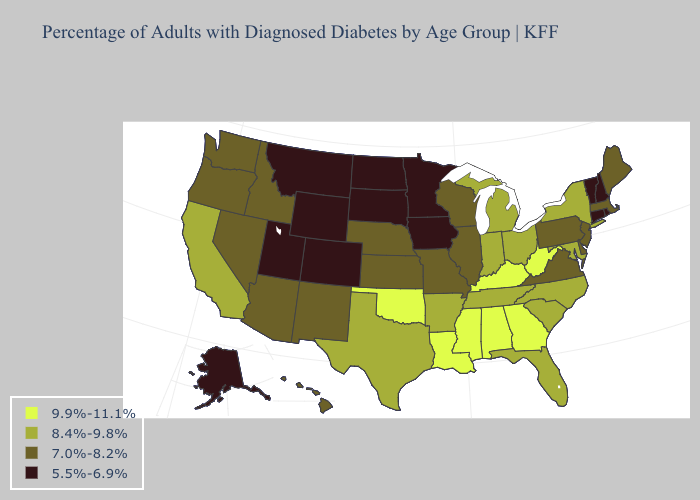What is the value of Arizona?
Give a very brief answer. 7.0%-8.2%. Name the states that have a value in the range 8.4%-9.8%?
Write a very short answer. Arkansas, California, Florida, Indiana, Maryland, Michigan, New York, North Carolina, Ohio, South Carolina, Tennessee, Texas. What is the highest value in states that border Indiana?
Be succinct. 9.9%-11.1%. Which states hav the highest value in the MidWest?
Short answer required. Indiana, Michigan, Ohio. What is the lowest value in states that border Montana?
Short answer required. 5.5%-6.9%. What is the value of Montana?
Short answer required. 5.5%-6.9%. Name the states that have a value in the range 8.4%-9.8%?
Give a very brief answer. Arkansas, California, Florida, Indiana, Maryland, Michigan, New York, North Carolina, Ohio, South Carolina, Tennessee, Texas. Does New Mexico have a higher value than Ohio?
Write a very short answer. No. Which states hav the highest value in the Northeast?
Give a very brief answer. New York. What is the highest value in states that border Maryland?
Concise answer only. 9.9%-11.1%. What is the value of Minnesota?
Answer briefly. 5.5%-6.9%. Name the states that have a value in the range 8.4%-9.8%?
Be succinct. Arkansas, California, Florida, Indiana, Maryland, Michigan, New York, North Carolina, Ohio, South Carolina, Tennessee, Texas. Name the states that have a value in the range 7.0%-8.2%?
Answer briefly. Arizona, Delaware, Hawaii, Idaho, Illinois, Kansas, Maine, Massachusetts, Missouri, Nebraska, Nevada, New Jersey, New Mexico, Oregon, Pennsylvania, Virginia, Washington, Wisconsin. Name the states that have a value in the range 5.5%-6.9%?
Concise answer only. Alaska, Colorado, Connecticut, Iowa, Minnesota, Montana, New Hampshire, North Dakota, Rhode Island, South Dakota, Utah, Vermont, Wyoming. Name the states that have a value in the range 8.4%-9.8%?
Write a very short answer. Arkansas, California, Florida, Indiana, Maryland, Michigan, New York, North Carolina, Ohio, South Carolina, Tennessee, Texas. 